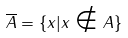<formula> <loc_0><loc_0><loc_500><loc_500>\overline { A } = \{ x | x \notin A \}</formula> 